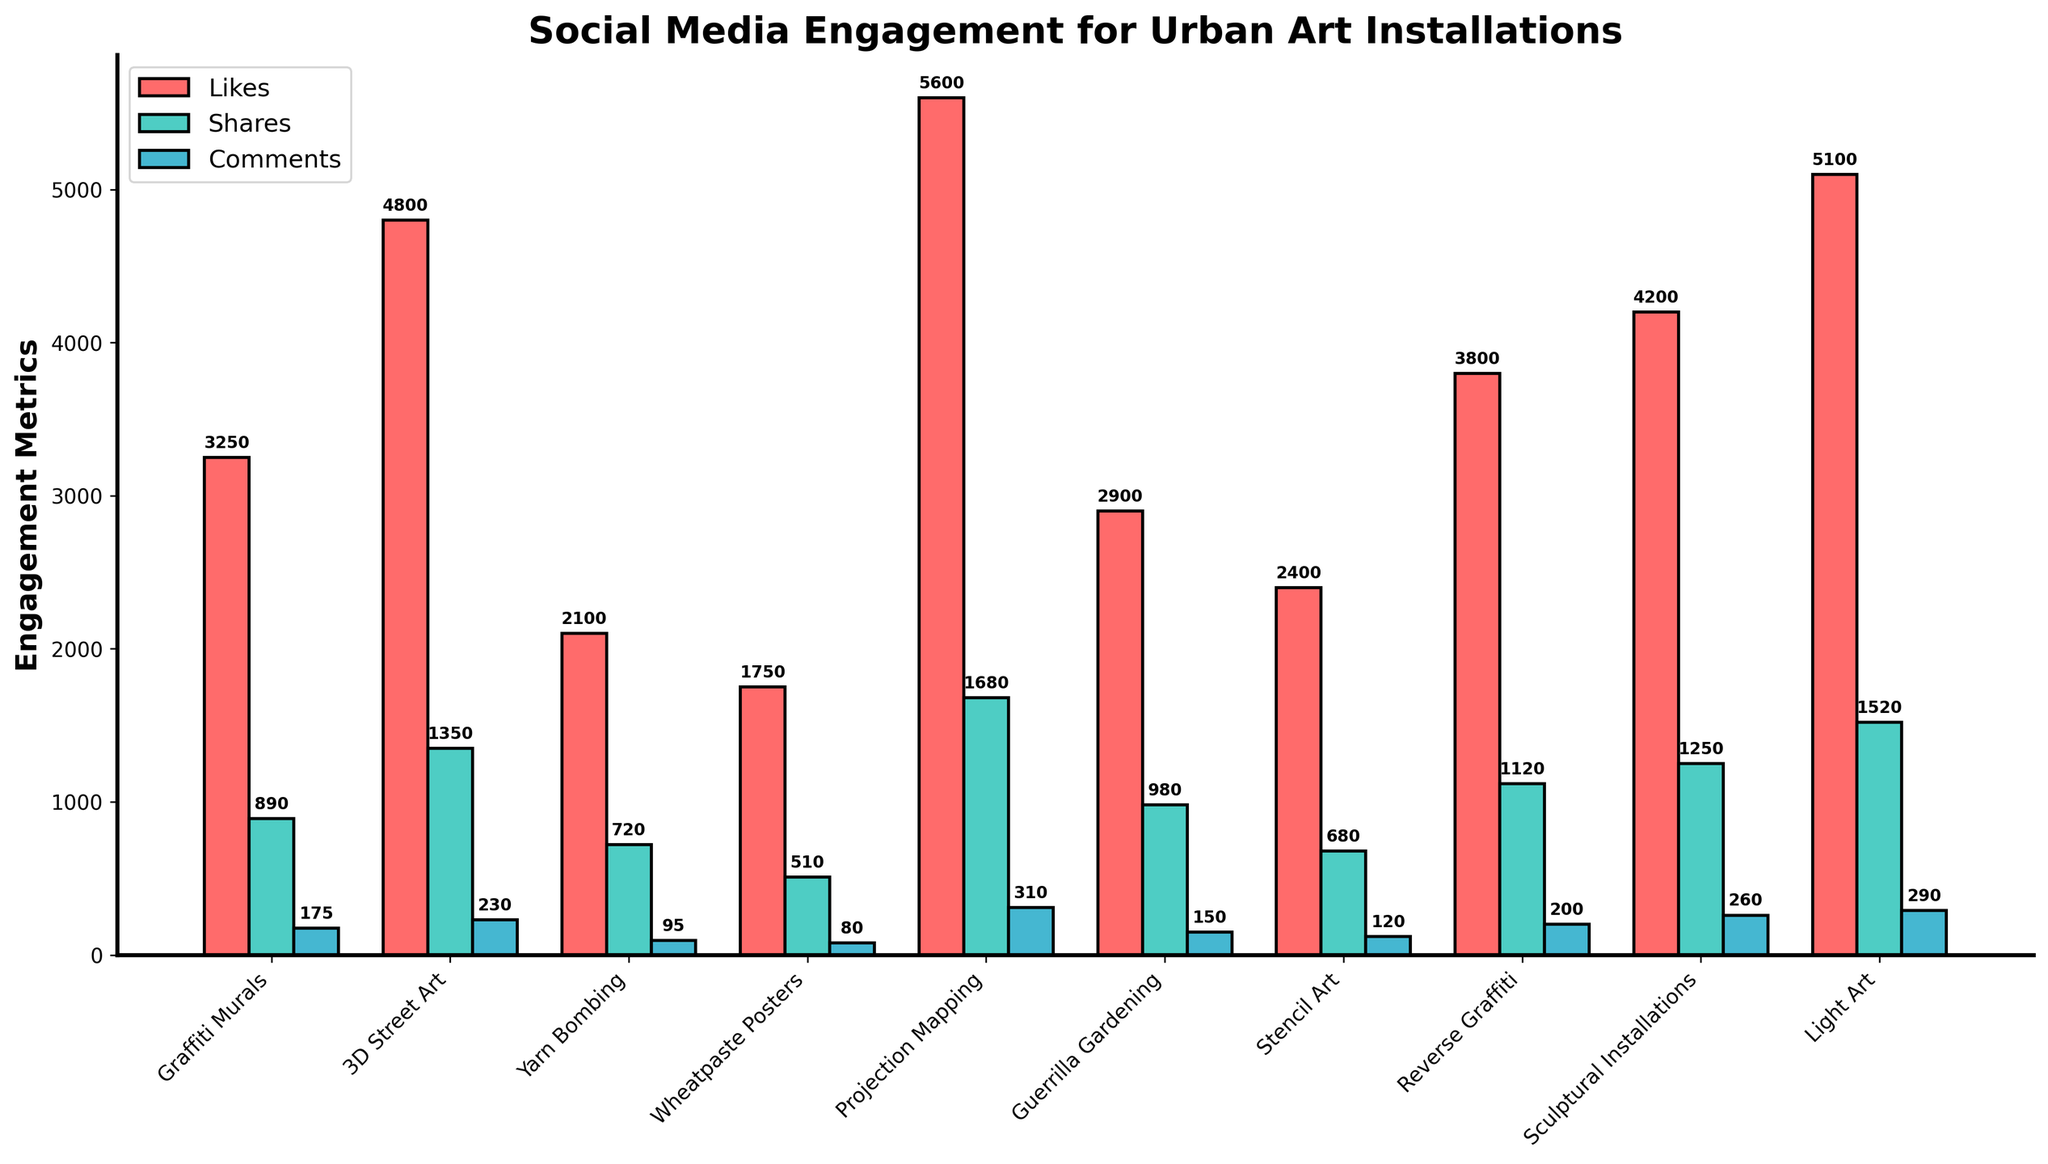Which type of urban art received the highest average likes? To find the type of urban art with the highest average likes, look for the tallest red bar in the chart. The tallest red bar corresponds to "Projection Mapping" with 5600 likes.
Answer: Projection Mapping How many more average comments does Light Art get compared to Yarn Bombing? Find the blue bar heights for Light Art and Yarn Bombing, which are 290 comments and 95 comments respectively. Subtract the two values: 290 - 95.
Answer: 195 Which type of art has the smallest average shares and how many shares does it have? Look for the shortest green bar in the chart, which corresponds to "Wheatpaste Posters" with 510 shares.
Answer: Wheatpaste Posters with 510 shares What is the total average number of likes for all the art types combined? Add the heights of all the red bars: 3250 + 4800 + 2100 + 1750 + 5600 + 2900 + 2400 + 3800 + 4200 + 5100.
Answer: 35,900 Is the average number of shares for Guerrilla Gardening greater than that for Reverse Graffiti? Compare the green bar heights for Guerrilla Gardening (980 shares) and Reverse Graffiti (1120 shares). Since 1120 is greater than 980, the average shares for Reverse Graffiti are higher.
Answer: No Which three types of urban art have the highest average comments, and what are the comment counts? Identify the three tallest blue bars. They correspond to "Projection Mapping" (310), "Light Art" (290), and "Sculptural Installations" (260).
Answer: Projection Mapping: 310, Light Art: 290, Sculptural Installations: 260 What is the combined average number of shares and comments for Graffiti Murals? Add the heights of the green and blue bars for Graffiti Murals: 890 (shares) + 175 (comments).
Answer: 1065 Are there any types of urban art where the average comments are more than half of the average shares? Compare the blue and green bar heights for each type. Projection Mapping satisfies this condition with comments (310) more than half of shares (1680/2 = 840).
Answer: Yes, Projection Mapping What is the average number of likes for Projection Mapping, 3D Street Art, and Light Art combined? Add the heights of the red bars: 5600 (Projection Mapping) + 4800 (3D Street Art) + 5100 (Light Art) and divide by 3 to find the average: (5600 + 4800 + 5100) / 3.
Answer: 5167#ifndef 